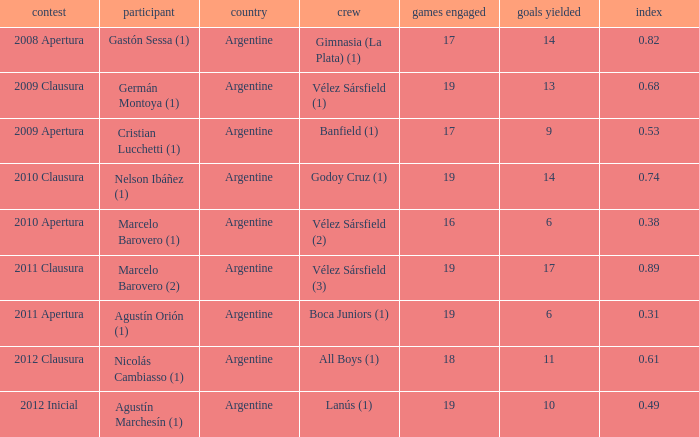 the 2010 clausura tournament? 0.74. 